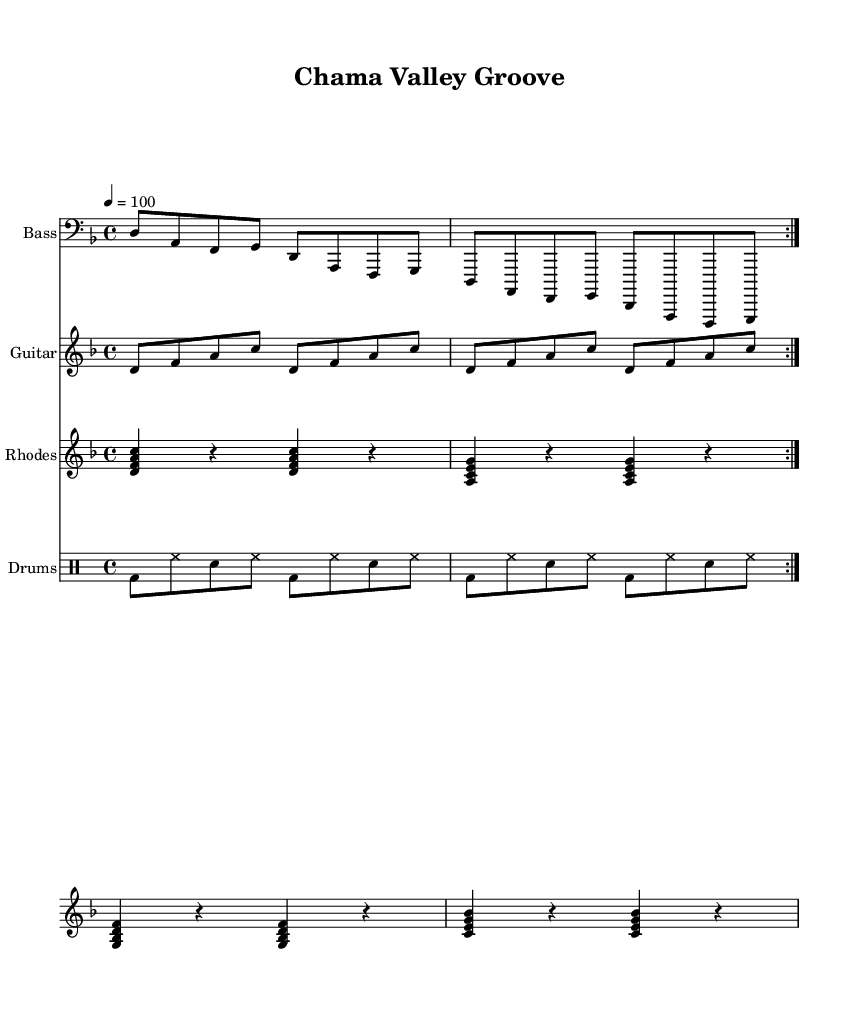What is the key signature of this music? The key signature is indicated at the beginning of the staff and shows two flats (B♭ and E♭), which defines the piece as being in D minor.
Answer: D minor What is the time signature of this music? The time signature is noted at the beginning of the piece and shows a 4/4 indication, which means there are four beats in each measure and a quarter note receives one beat.
Answer: 4/4 What is the tempo marking of this music? The tempo is stated in beats per minute at the start, showing that the piece should be played at a speed of 100 beats per minute.
Answer: 100 How many times is the bass line repeated? The bass line is marked with a "volta" indication that directs the performer to repeat the section twice, indicating a specific repeated structure in the music.
Answer: 2 What is the main instrument featured in this piece? The title and the main staff at the top indicate that the bass is the featured instrument, as it is specified first in the parts layout.
Answer: Bass What rhythmic element is most prominent in the drums part? The drums part shows a consistent pattern of bass drum and snare, where the bass drum (bd) is played on the first and third beats, and the snare (sn) is heard on the second and fourth, creating a prominent backbeat typical of funk music.
Answer: Backbeat What type of chords does the Rhodes part primarily utilize? The Rhodes part is made up of sustain chords primarily featuring triads that are common in funk music, enhancing the harmonic texture and groove of the piece.
Answer: Triads 